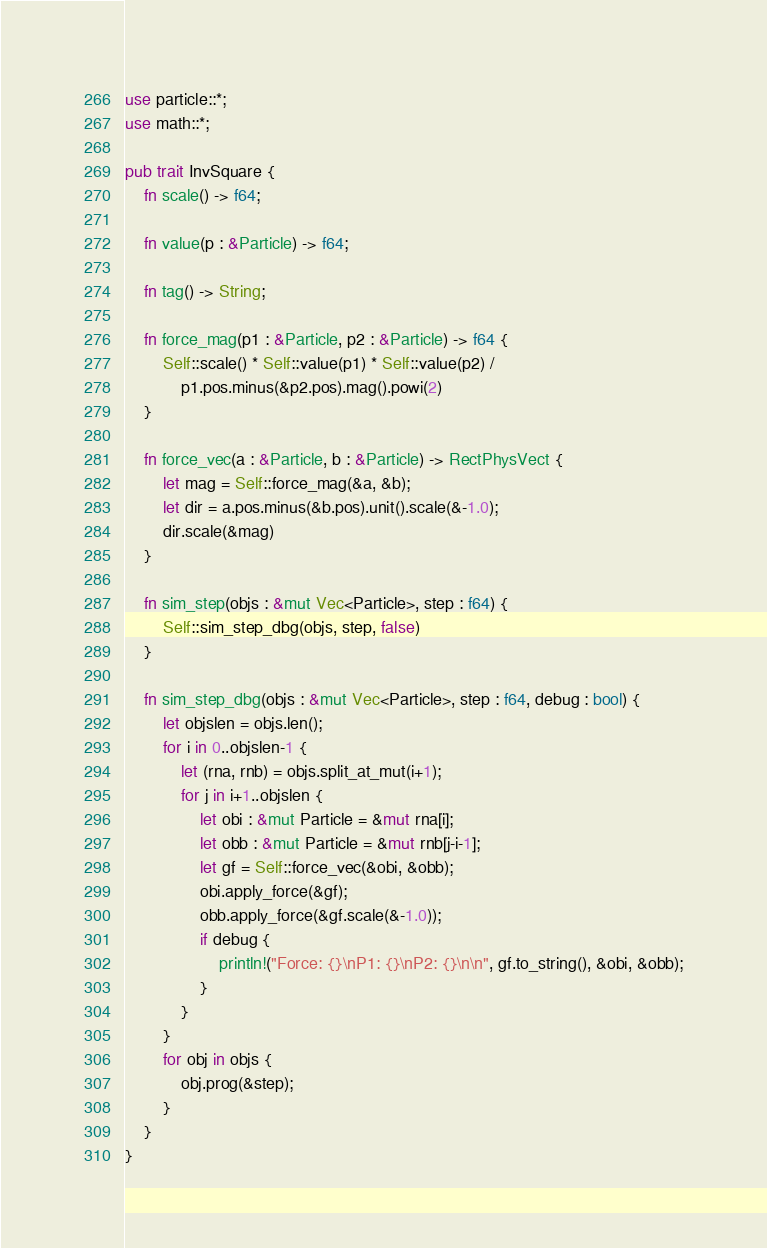Convert code to text. <code><loc_0><loc_0><loc_500><loc_500><_Rust_>use particle::*;
use math::*;

pub trait InvSquare {
    fn scale() -> f64;

    fn value(p : &Particle) -> f64;

    fn tag() -> String;

    fn force_mag(p1 : &Particle, p2 : &Particle) -> f64 {
        Self::scale() * Self::value(p1) * Self::value(p2) /
            p1.pos.minus(&p2.pos).mag().powi(2)
    }

    fn force_vec(a : &Particle, b : &Particle) -> RectPhysVect {
        let mag = Self::force_mag(&a, &b);
        let dir = a.pos.minus(&b.pos).unit().scale(&-1.0);
        dir.scale(&mag)
    }

    fn sim_step(objs : &mut Vec<Particle>, step : f64) {
        Self::sim_step_dbg(objs, step, false)
    }

    fn sim_step_dbg(objs : &mut Vec<Particle>, step : f64, debug : bool) {
        let objslen = objs.len();
        for i in 0..objslen-1 {
            let (rna, rnb) = objs.split_at_mut(i+1);
            for j in i+1..objslen {
                let obi : &mut Particle = &mut rna[i];
                let obb : &mut Particle = &mut rnb[j-i-1];
                let gf = Self::force_vec(&obi, &obb);
                obi.apply_force(&gf);
                obb.apply_force(&gf.scale(&-1.0));
                if debug {
                    println!("Force: {}\nP1: {}\nP2: {}\n\n", gf.to_string(), &obi, &obb);
                }
            }
        }
        for obj in objs {
            obj.prog(&step);
        }
    }
}</code> 